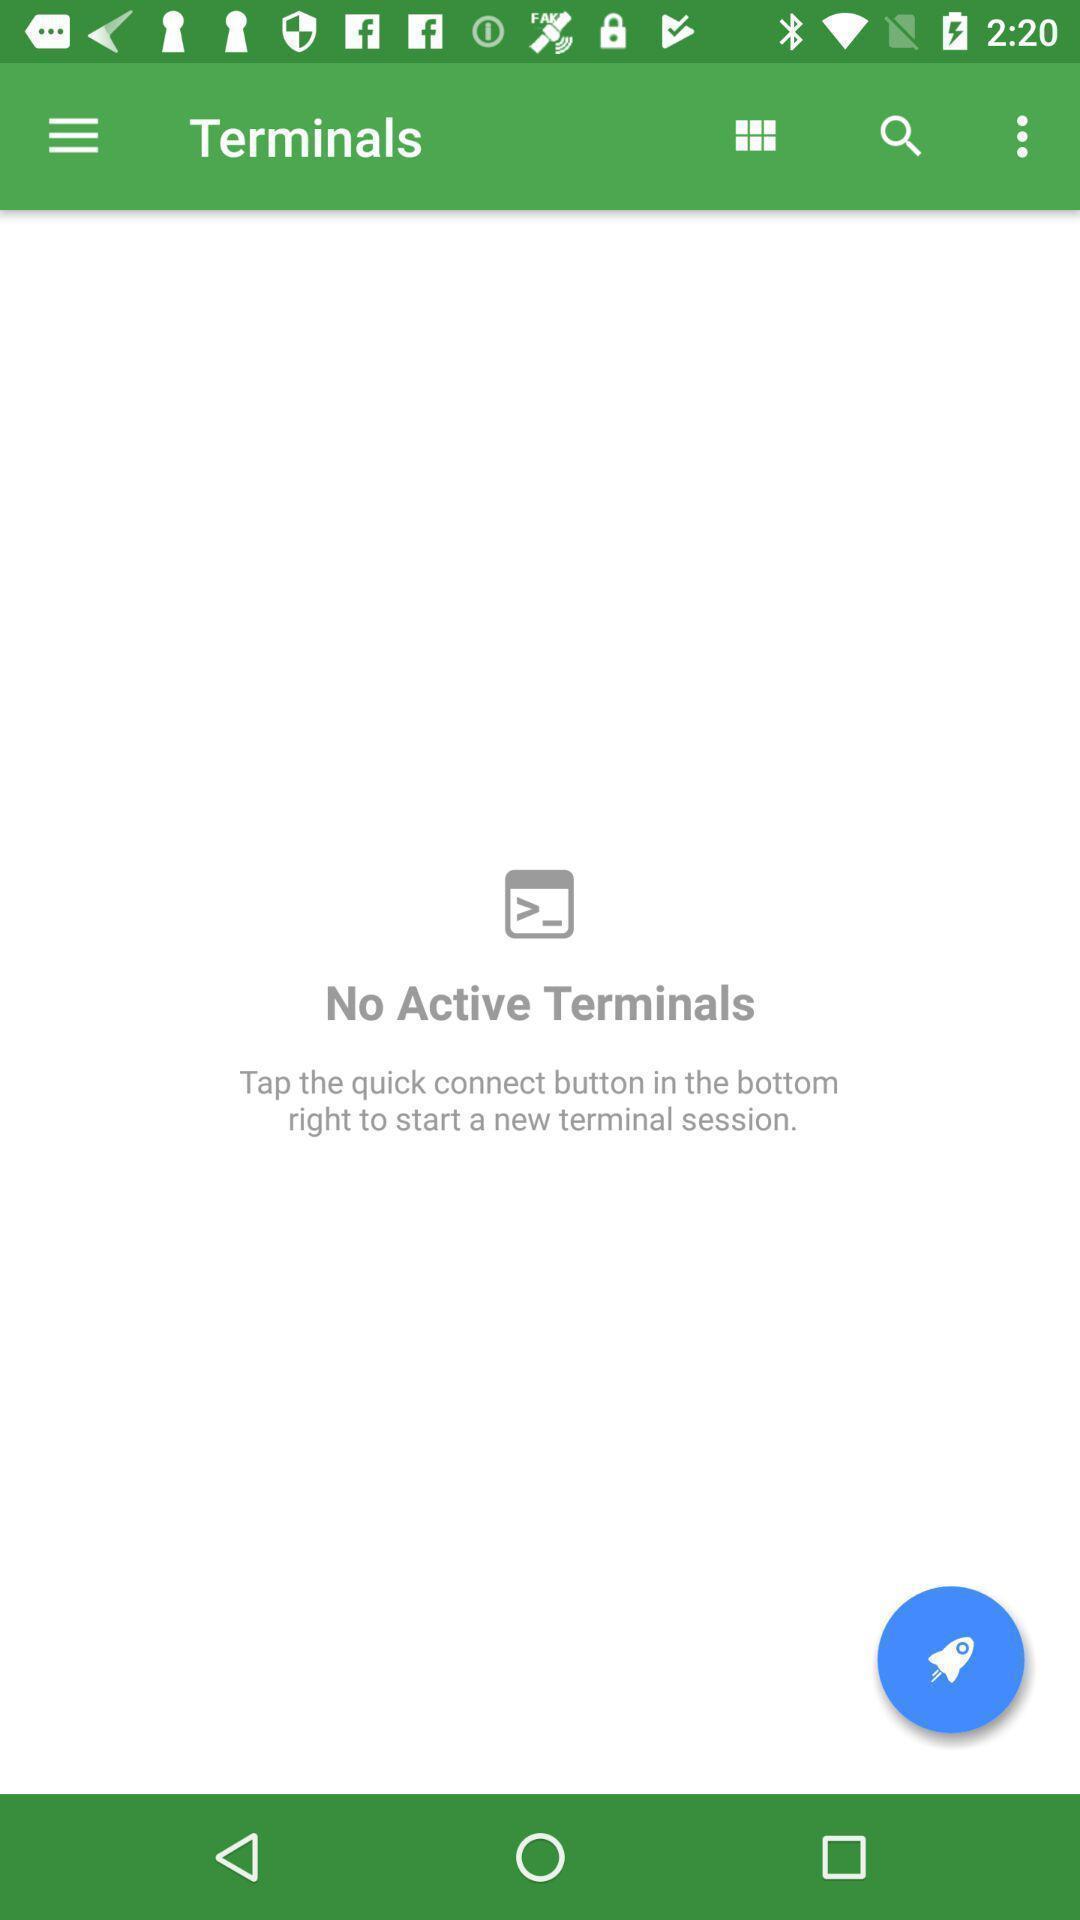What is the overall content of this screenshot? Screen displaying the terminals page. 